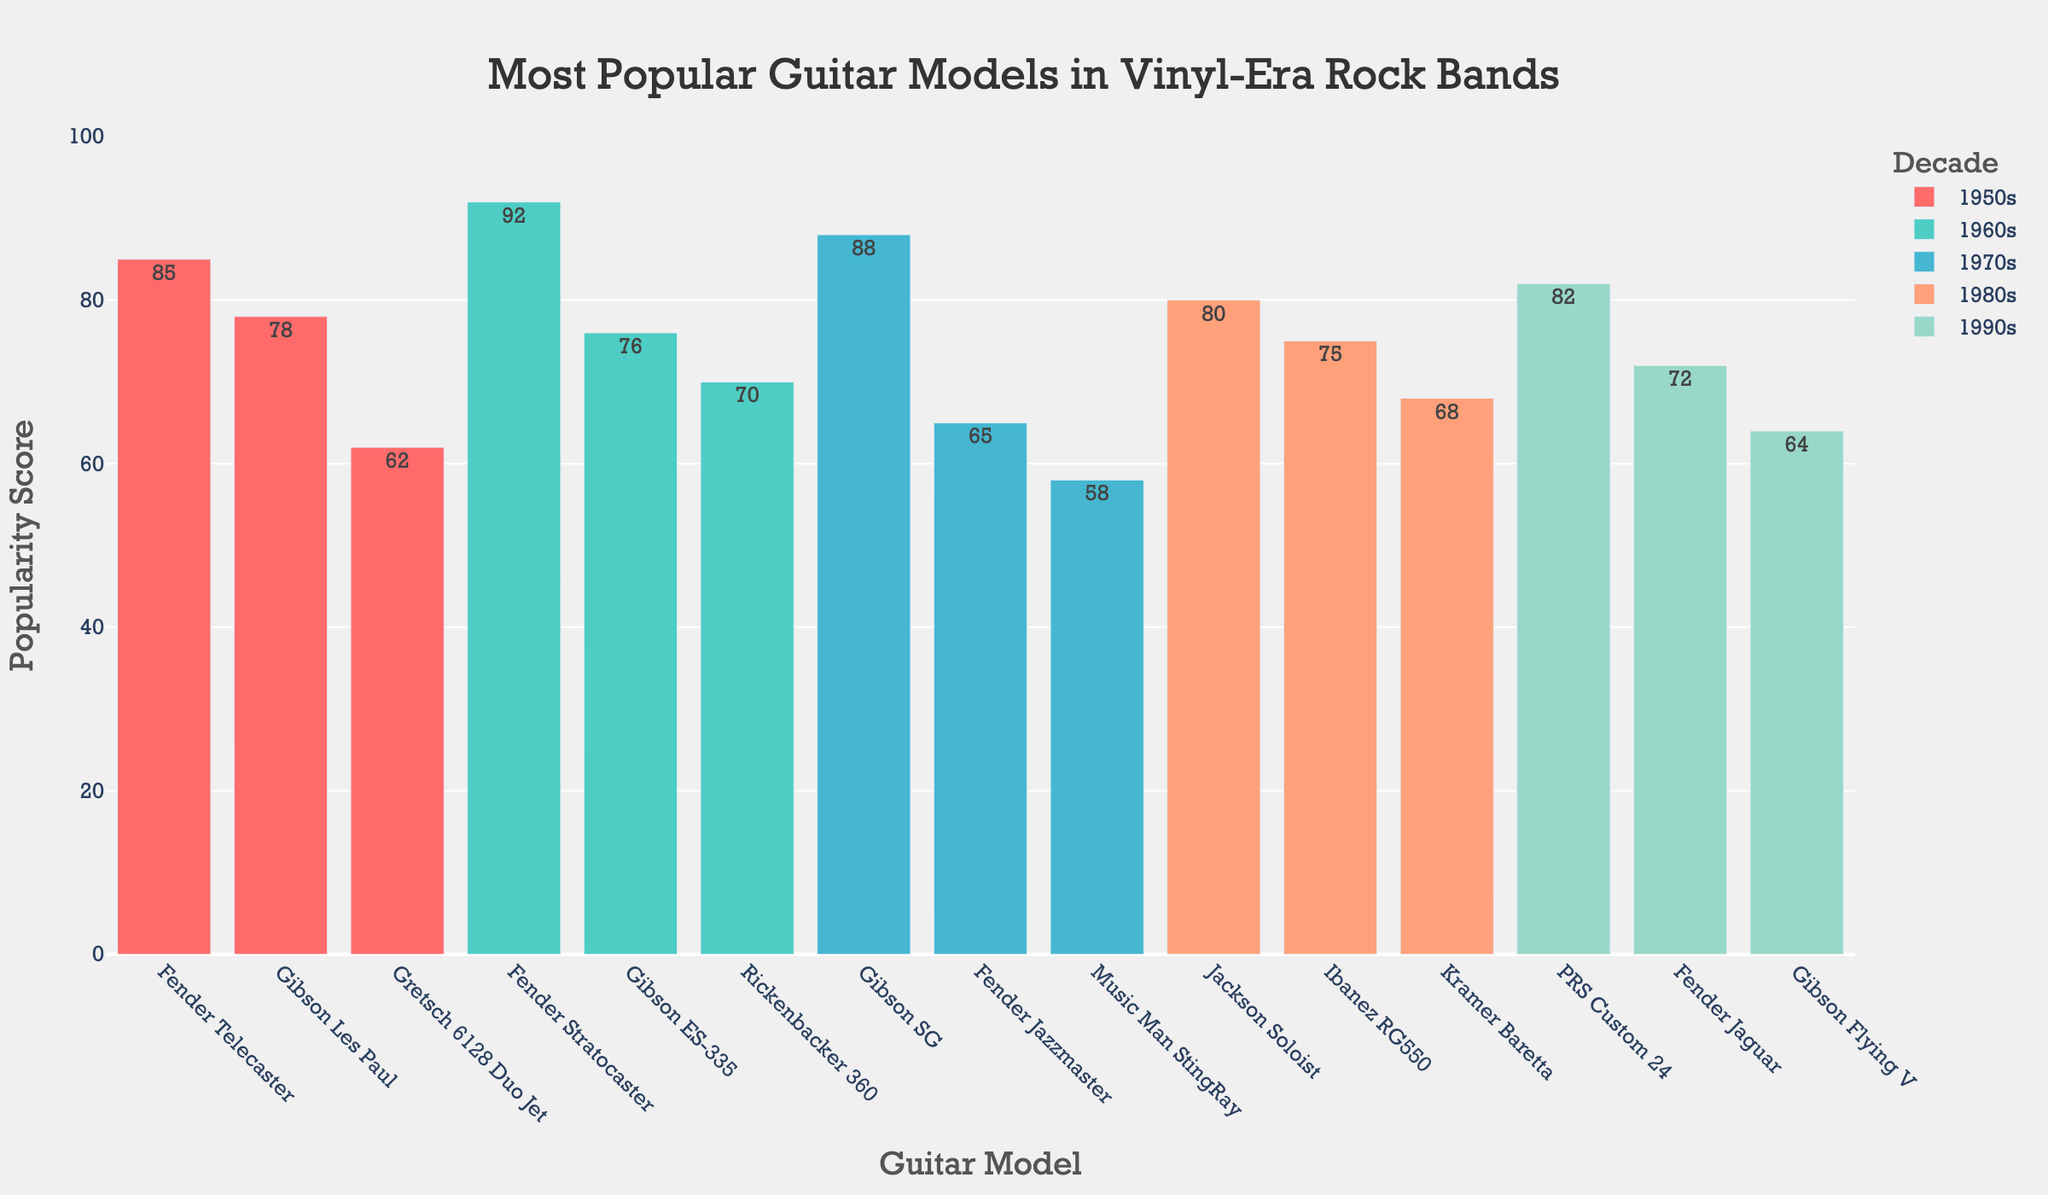Which decade had the highest popularity score for a guitar model? Look at each decade and find the highest bar representing the popularity scores. For the 1960s, the Fender Stratocaster has a score of 92, which is the highest across all decades.
Answer: 1960s Which guitar model had the highest popularity score in the 1970s? Observe the bars corresponding to the 1970s and compare their heights. The Gibson SG with a score of 88 is the tallest.
Answer: Gibson SG Which decade features the Fender Jaguar, and what is its popularity score? Identify the bar representing the Fender Jaguar, which falls under the 1990s category with a score of 72.
Answer: 1990s, 72 What is the sum of the popularity scores for the Gibson guitar models in the 1980s and 1990s combined? Locate the Gibson guitar models for the 1980s (none) and 1990s (Flying V, 64). Sum their scores: 64.
Answer: 64 How many more popularity points does the Fender Telecaster have in the 1950s compared to the Gibson Les Paul? The Fender Telecaster has an 85 score while the Gibson Les Paul has 78. The difference is 85 - 78 = 7 points.
Answer: 7 Which decade had the most diversity in guitar models, and how many different models were there in that decade? Count the number of distinct guitar models for each decade. The 1960s and 1990s both have three different models, the highest.
Answer: 1960s and 1990s, 3 What is the average popularity score for the guitar models in the 1980s? Add the scores of the three guitar models in the 1980s: (80 + 75 + 68 = 223), then divide by 3: 223 / 3 ≈ 74.33.
Answer: 74.33 Which decade had the lowest average popularity score? Calculate the average for each decade: 1950s (75), 1960s (79.33), 1970s (70.33), 1980s (74.33), 1990s (72.67). The 1970s has the lowest average score at 70.33.
Answer: 1970s What is the total popularity score for all guitar models in the dataset combined? Sum the popularity scores for all guitar models across all decades: (85 + 78 + 62 + 92 + 76 + 70 + 88 + 65 + 58 + 80 + 75 + 68 + 82 + 72 + 64) = 1035.
Answer: 1035 